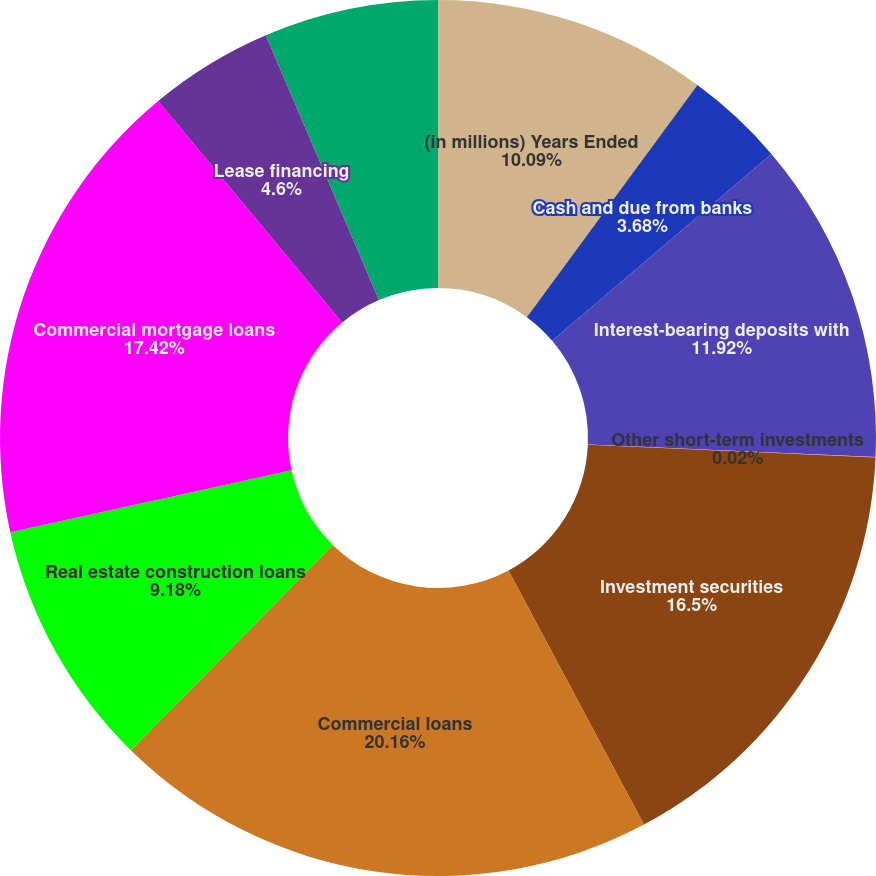Convert chart to OTSL. <chart><loc_0><loc_0><loc_500><loc_500><pie_chart><fcel>(in millions) Years Ended<fcel>Cash and due from banks<fcel>Interest-bearing deposits with<fcel>Other short-term investments<fcel>Investment securities<fcel>Commercial loans<fcel>Real estate construction loans<fcel>Commercial mortgage loans<fcel>Lease financing<fcel>International loans<nl><fcel>10.09%<fcel>3.68%<fcel>11.92%<fcel>0.02%<fcel>16.5%<fcel>20.16%<fcel>9.18%<fcel>17.42%<fcel>4.6%<fcel>6.43%<nl></chart> 